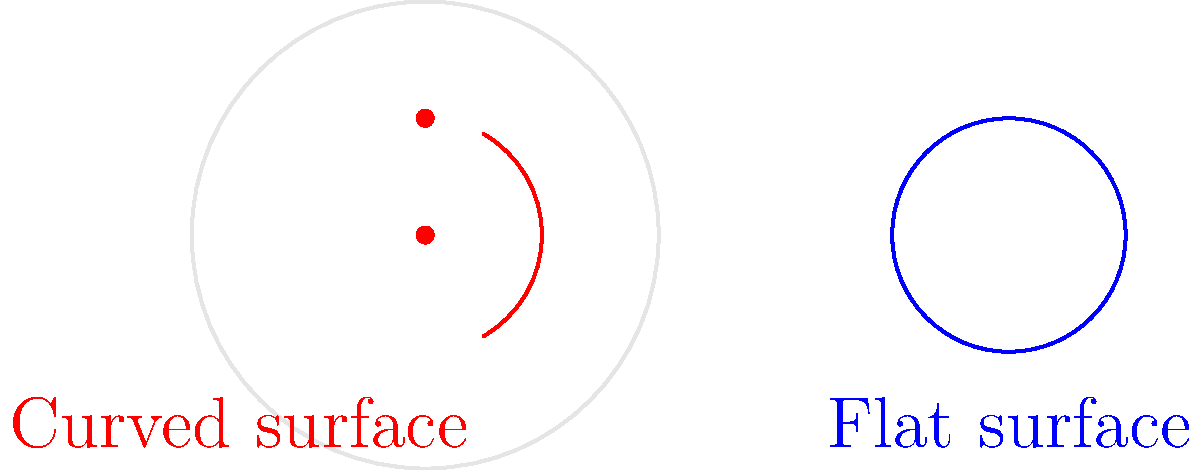As a firefighter, you often deal with various surface types when deploying equipment. Consider two identical circles with radius $r$, one drawn on a flat surface and another on a sphere with radius $R$. If $r = \frac{R}{2}$, what is the ratio of the area of the circle on the sphere to the area of the circle on the flat surface? Let's approach this step-by-step:

1) For the circle on the flat surface:
   Area = $\pi r^2$

2) For the circle on the sphere:
   We need to use the formula for the area of a spherical cap:
   Area = $2\pi R h$, where $h$ is the height of the cap

3) To find $h$, we can use the Pythagorean theorem:
   $R^2 = (R-h)^2 + r^2$

4) Given that $r = \frac{R}{2}$, let's substitute:
   $R^2 = (R-h)^2 + (\frac{R}{2})^2$

5) Simplify:
   $R^2 = R^2 - 2Rh + h^2 + \frac{R^2}{4}$

6) Cancel $R^2$ on both sides:
   $0 = -2Rh + h^2 + \frac{R^2}{4}$

7) Solve for $h$:
   $h = R - \frac{\sqrt{3}R}{2} \approx 0.134R$

8) Now, let's calculate the areas:
   Flat circle: $A_f = \pi (\frac{R}{2})^2 = \frac{\pi R^2}{4}$
   Sphere circle: $A_s = 2\pi R (R - \frac{\sqrt{3}R}{2}) = \pi R^2 (1 - \frac{\sqrt{3}}{2})$

9) The ratio is:
   $\frac{A_s}{A_f} = \frac{\pi R^2 (1 - \frac{\sqrt{3}}{2})}{\frac{\pi R^2}{4}} = 4(1 - \frac{\sqrt{3}}{2}) \approx 0.536$
Answer: $4(1 - \frac{\sqrt{3}}{2}) \approx 0.536$ 